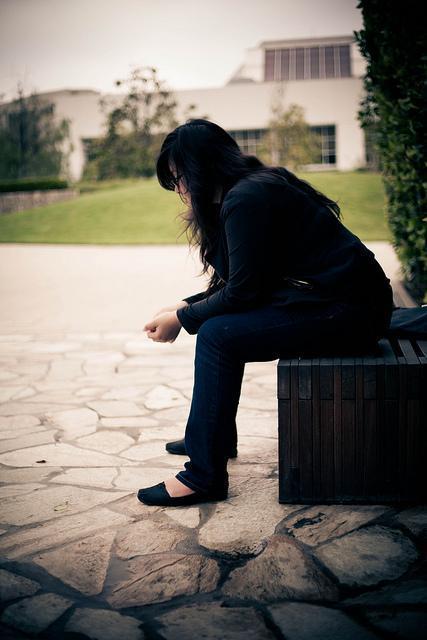How many people are in the picture?
Give a very brief answer. 1. 